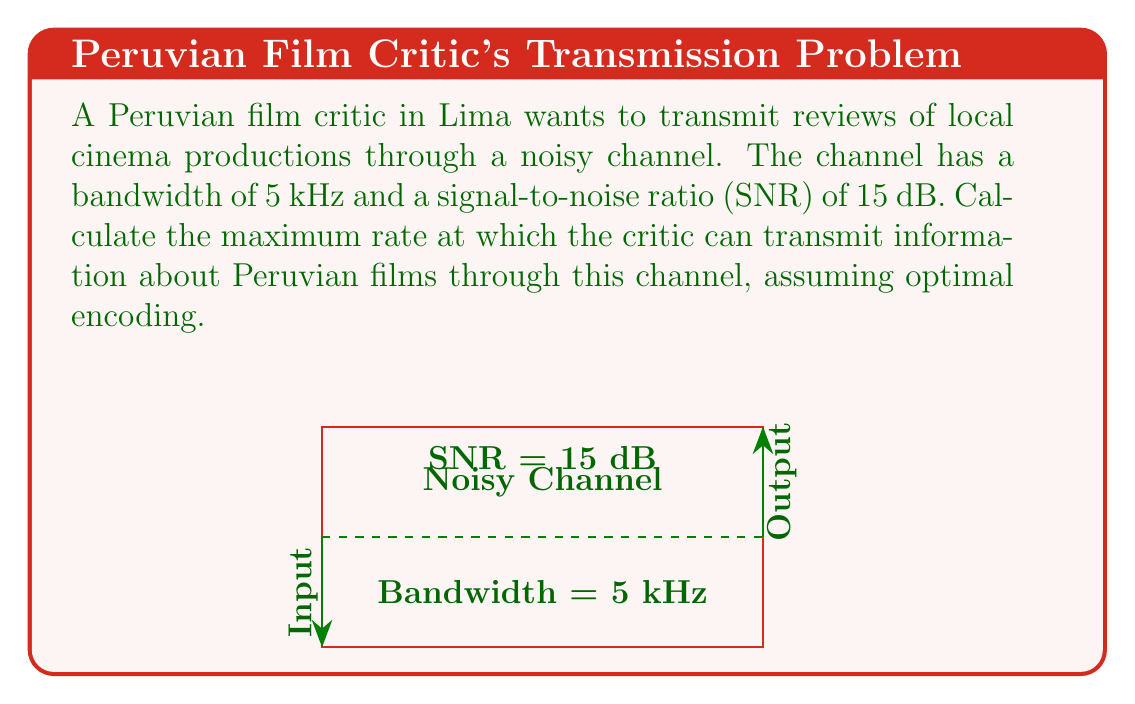Provide a solution to this math problem. To solve this problem, we'll use the Shannon-Hartley theorem, which gives the channel capacity for a noisy channel with a given bandwidth and signal-to-noise ratio.

The Shannon-Hartley theorem states that:

$$C = B \log_2(1 + \text{SNR})$$

Where:
- $C$ is the channel capacity in bits per second (bps)
- $B$ is the bandwidth in Hz
- $\text{SNR}$ is the linear signal-to-noise ratio

Steps to solve:

1) We're given the bandwidth $B = 5 \text{ kHz} = 5000 \text{ Hz}$

2) The SNR is given in decibels (dB). We need to convert it to a linear ratio:
   $\text{SNR}_{\text{linear}} = 10^{\frac{\text{SNR}_{\text{dB}}}{10}} = 10^{\frac{15}{10}} = 10^{1.5} \approx 31.6228$

3) Now we can apply the Shannon-Hartley theorem:

   $$C = 5000 \log_2(1 + 31.6228)$$

4) Calculate:
   $$C = 5000 \log_2(32.6228)$$
   $$C = 5000 * 5.0279$$
   $$C = 25139.5 \text{ bps}$$

5) Round to a reasonable number of significant figures:
   $$C \approx 25140 \text{ bps}$$

This means the Peruvian film critic can transmit information about local cinema at a maximum rate of about 25,140 bits per second, assuming optimal encoding.
Answer: 25140 bps 